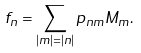<formula> <loc_0><loc_0><loc_500><loc_500>f _ { n } = \sum _ { | m | = | n | } p _ { n m } M _ { m } .</formula> 